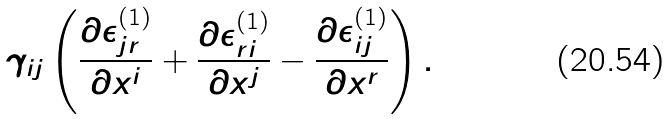Convert formula to latex. <formula><loc_0><loc_0><loc_500><loc_500>\gamma _ { i j } \left ( \frac { \partial \epsilon _ { j r } ^ { ( 1 ) } } { \partial x ^ { i } } + \frac { \partial \epsilon _ { r i } ^ { ( 1 ) } } { \partial x ^ { j } } - \frac { \partial \epsilon _ { i j } ^ { ( 1 ) } } { \partial x ^ { r } } \right ) .</formula> 